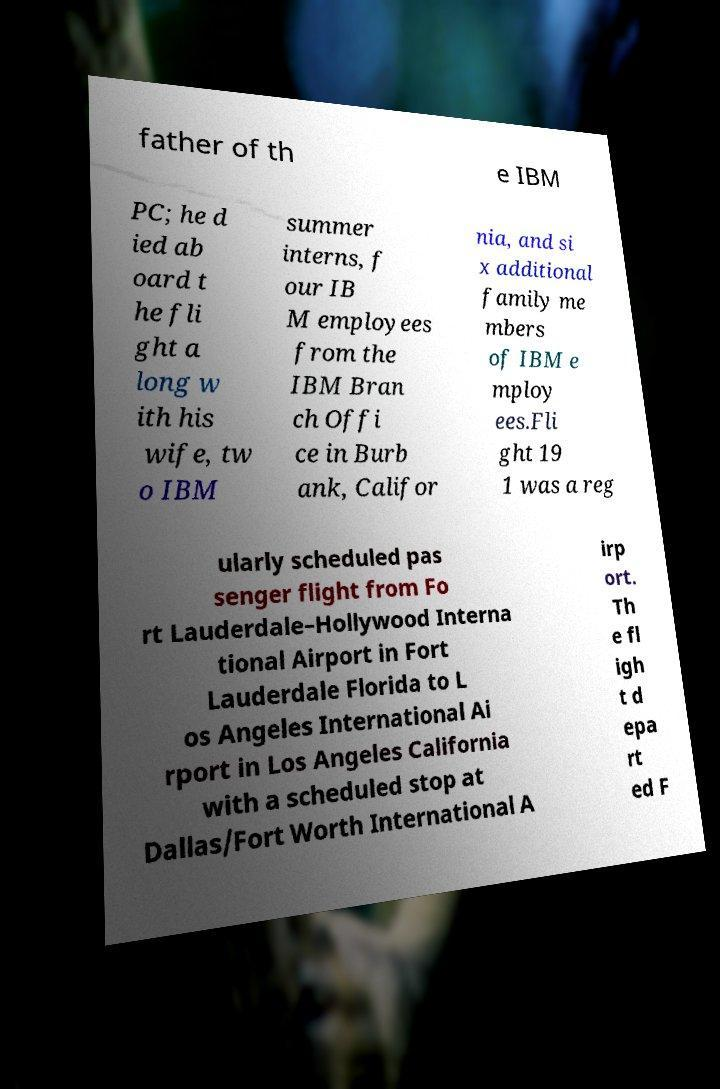Please identify and transcribe the text found in this image. father of th e IBM PC; he d ied ab oard t he fli ght a long w ith his wife, tw o IBM summer interns, f our IB M employees from the IBM Bran ch Offi ce in Burb ank, Califor nia, and si x additional family me mbers of IBM e mploy ees.Fli ght 19 1 was a reg ularly scheduled pas senger flight from Fo rt Lauderdale–Hollywood Interna tional Airport in Fort Lauderdale Florida to L os Angeles International Ai rport in Los Angeles California with a scheduled stop at Dallas/Fort Worth International A irp ort. Th e fl igh t d epa rt ed F 